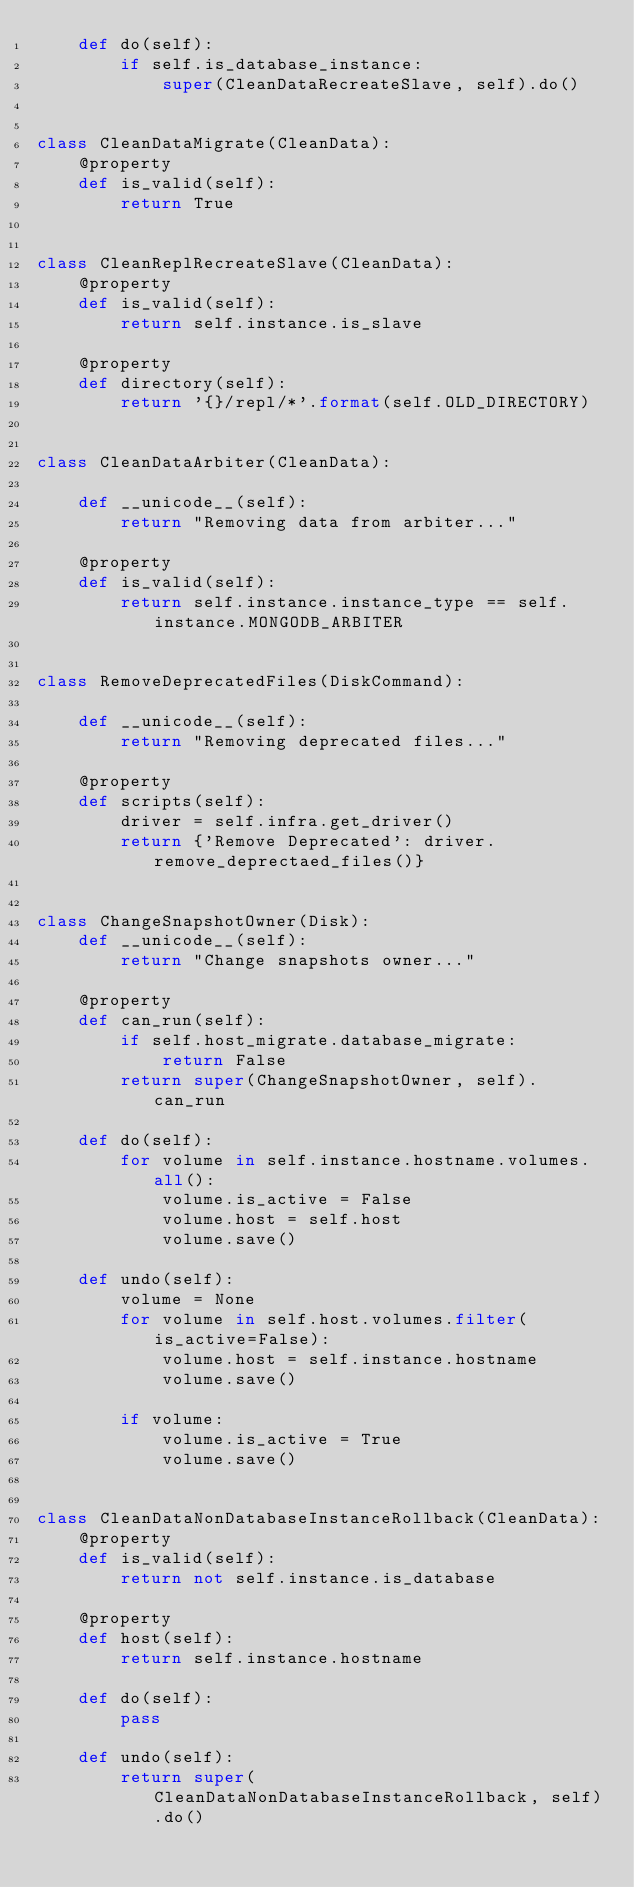<code> <loc_0><loc_0><loc_500><loc_500><_Python_>    def do(self):
        if self.is_database_instance:
            super(CleanDataRecreateSlave, self).do()


class CleanDataMigrate(CleanData):
    @property
    def is_valid(self):
        return True


class CleanReplRecreateSlave(CleanData):
    @property
    def is_valid(self):
        return self.instance.is_slave

    @property
    def directory(self):
        return '{}/repl/*'.format(self.OLD_DIRECTORY)


class CleanDataArbiter(CleanData):

    def __unicode__(self):
        return "Removing data from arbiter..."

    @property
    def is_valid(self):
        return self.instance.instance_type == self.instance.MONGODB_ARBITER


class RemoveDeprecatedFiles(DiskCommand):

    def __unicode__(self):
        return "Removing deprecated files..."

    @property
    def scripts(self):
        driver = self.infra.get_driver()
        return {'Remove Deprecated': driver.remove_deprectaed_files()}


class ChangeSnapshotOwner(Disk):
    def __unicode__(self):
        return "Change snapshots owner..."

    @property
    def can_run(self):
        if self.host_migrate.database_migrate:
            return False
        return super(ChangeSnapshotOwner, self).can_run

    def do(self):
        for volume in self.instance.hostname.volumes.all():
            volume.is_active = False
            volume.host = self.host
            volume.save()

    def undo(self):
        volume = None
        for volume in self.host.volumes.filter(is_active=False):
            volume.host = self.instance.hostname
            volume.save()

        if volume:
            volume.is_active = True
            volume.save()


class CleanDataNonDatabaseInstanceRollback(CleanData):
    @property
    def is_valid(self):
        return not self.instance.is_database

    @property
    def host(self):
        return self.instance.hostname

    def do(self):
        pass

    def undo(self):
        return super(CleanDataNonDatabaseInstanceRollback, self).do()
</code> 